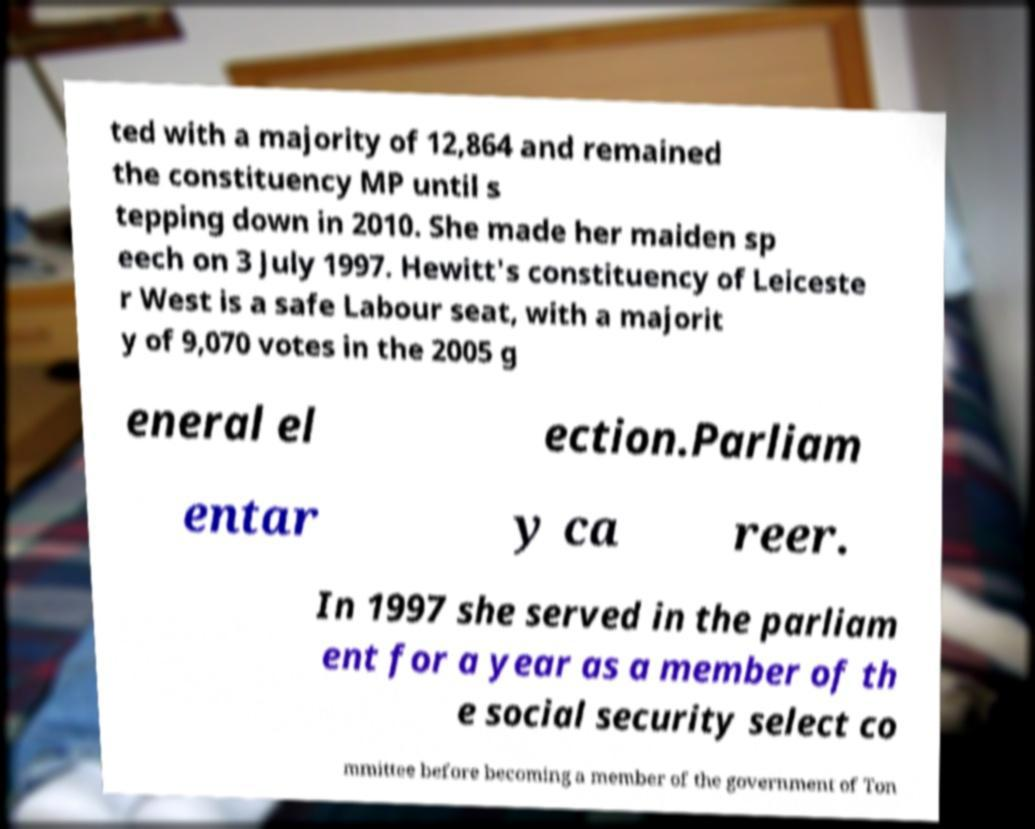There's text embedded in this image that I need extracted. Can you transcribe it verbatim? ted with a majority of 12,864 and remained the constituency MP until s tepping down in 2010. She made her maiden sp eech on 3 July 1997. Hewitt's constituency of Leiceste r West is a safe Labour seat, with a majorit y of 9,070 votes in the 2005 g eneral el ection.Parliam entar y ca reer. In 1997 she served in the parliam ent for a year as a member of th e social security select co mmittee before becoming a member of the government of Ton 